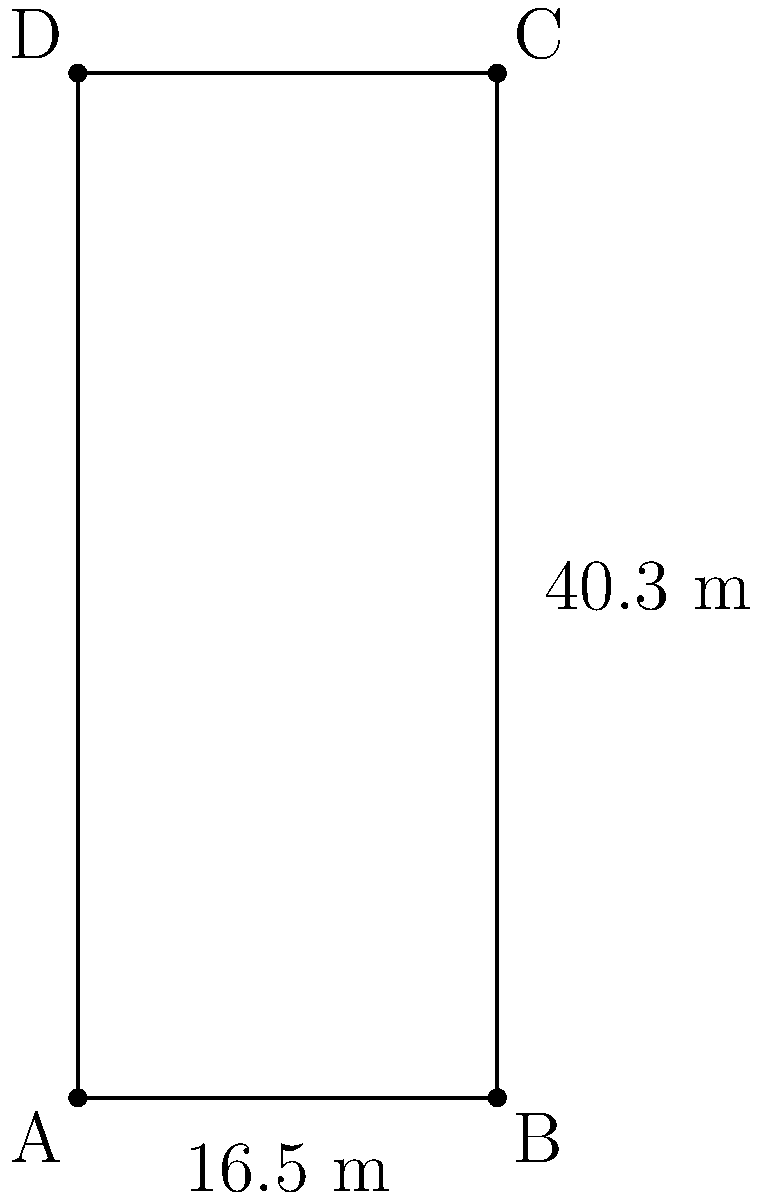As a football commentator, you're discussing the dimensions of the penalty area during a match in Chile. The penalty box measures 16.5 meters wide and 40.3 meters long. What is the total area of the penalty box in square meters? To find the area of the penalty box, we need to follow these steps:

1. Identify the shape: The penalty box is a rectangle.

2. Recall the formula for the area of a rectangle:
   Area = length $\times$ width

3. Substitute the given dimensions:
   Length = 40.3 meters
   Width = 16.5 meters

4. Calculate the area:
   Area = 40.3 m $\times$ 16.5 m
        = 664.95 m²

Therefore, the total area of the penalty box is 664.95 square meters.
Answer: 664.95 m² 